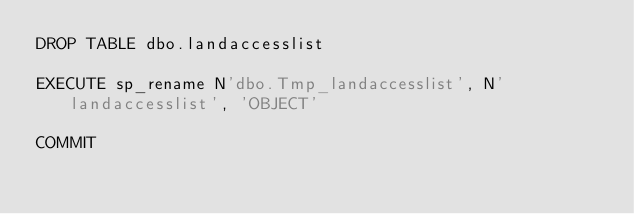<code> <loc_0><loc_0><loc_500><loc_500><_SQL_>DROP TABLE dbo.landaccesslist

EXECUTE sp_rename N'dbo.Tmp_landaccesslist', N'landaccesslist', 'OBJECT' 

COMMIT
</code> 